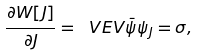Convert formula to latex. <formula><loc_0><loc_0><loc_500><loc_500>\frac { \partial W [ J ] } { \partial J } = \ V E V { \bar { \psi } \psi } _ { J } = \sigma ,</formula> 